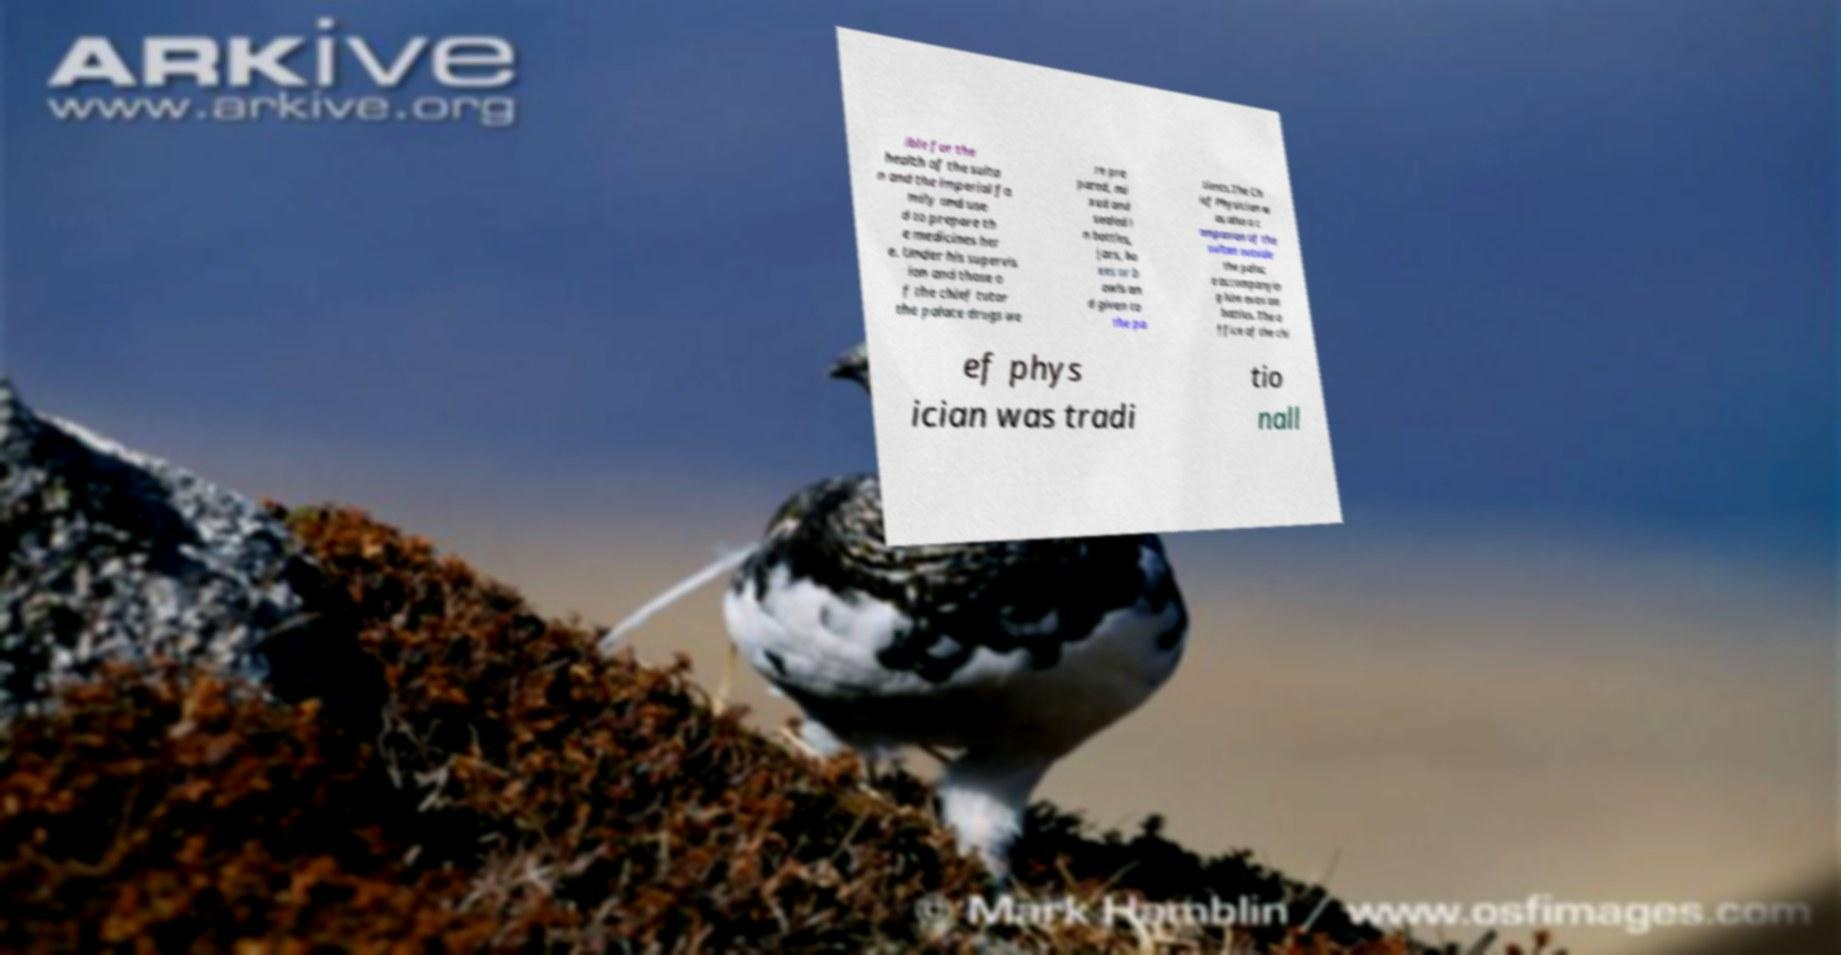For documentation purposes, I need the text within this image transcribed. Could you provide that? ible for the health of the sulta n and the imperial fa mily and use d to prepare th e medicines her e. Under his supervis ion and those o f the chief tutor the palace drugs we re pre pared, mi xed and sealed i n bottles, jars, bo xes or b owls an d given to the pa tients.The Ch ief Physician w as also a c ompanion of the sultan outside the palac e accompanyin g him even on battles. The o ffice of the chi ef phys ician was tradi tio nall 